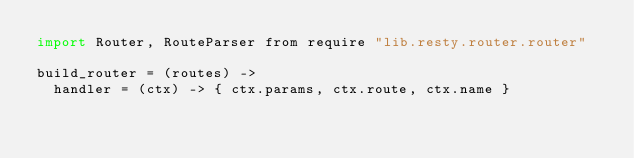<code> <loc_0><loc_0><loc_500><loc_500><_MoonScript_>import Router, RouteParser from require "lib.resty.router.router"

build_router = (routes) ->
  handler = (ctx) -> { ctx.params, ctx.route, ctx.name }</code> 